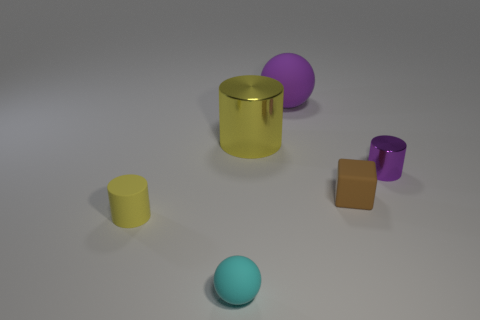What number of shiny things are either blue spheres or cyan objects?
Keep it short and to the point. 0. Are there fewer tiny cyan matte cylinders than big yellow shiny cylinders?
Provide a short and direct response. Yes. Does the purple metallic cylinder have the same size as the matte sphere in front of the large yellow thing?
Provide a succinct answer. Yes. Is there any other thing that is the same shape as the purple metallic object?
Keep it short and to the point. Yes. What size is the cyan object?
Provide a short and direct response. Small. Is the number of big purple rubber things that are to the left of the large rubber ball less than the number of rubber balls?
Offer a very short reply. Yes. Do the purple cylinder and the rubber block have the same size?
Make the answer very short. Yes. Is there any other thing that has the same size as the cyan sphere?
Your answer should be compact. Yes. What is the color of the tiny ball that is the same material as the cube?
Ensure brevity in your answer.  Cyan. Is the number of purple objects that are in front of the big rubber ball less than the number of small things that are in front of the tiny yellow object?
Ensure brevity in your answer.  No. 